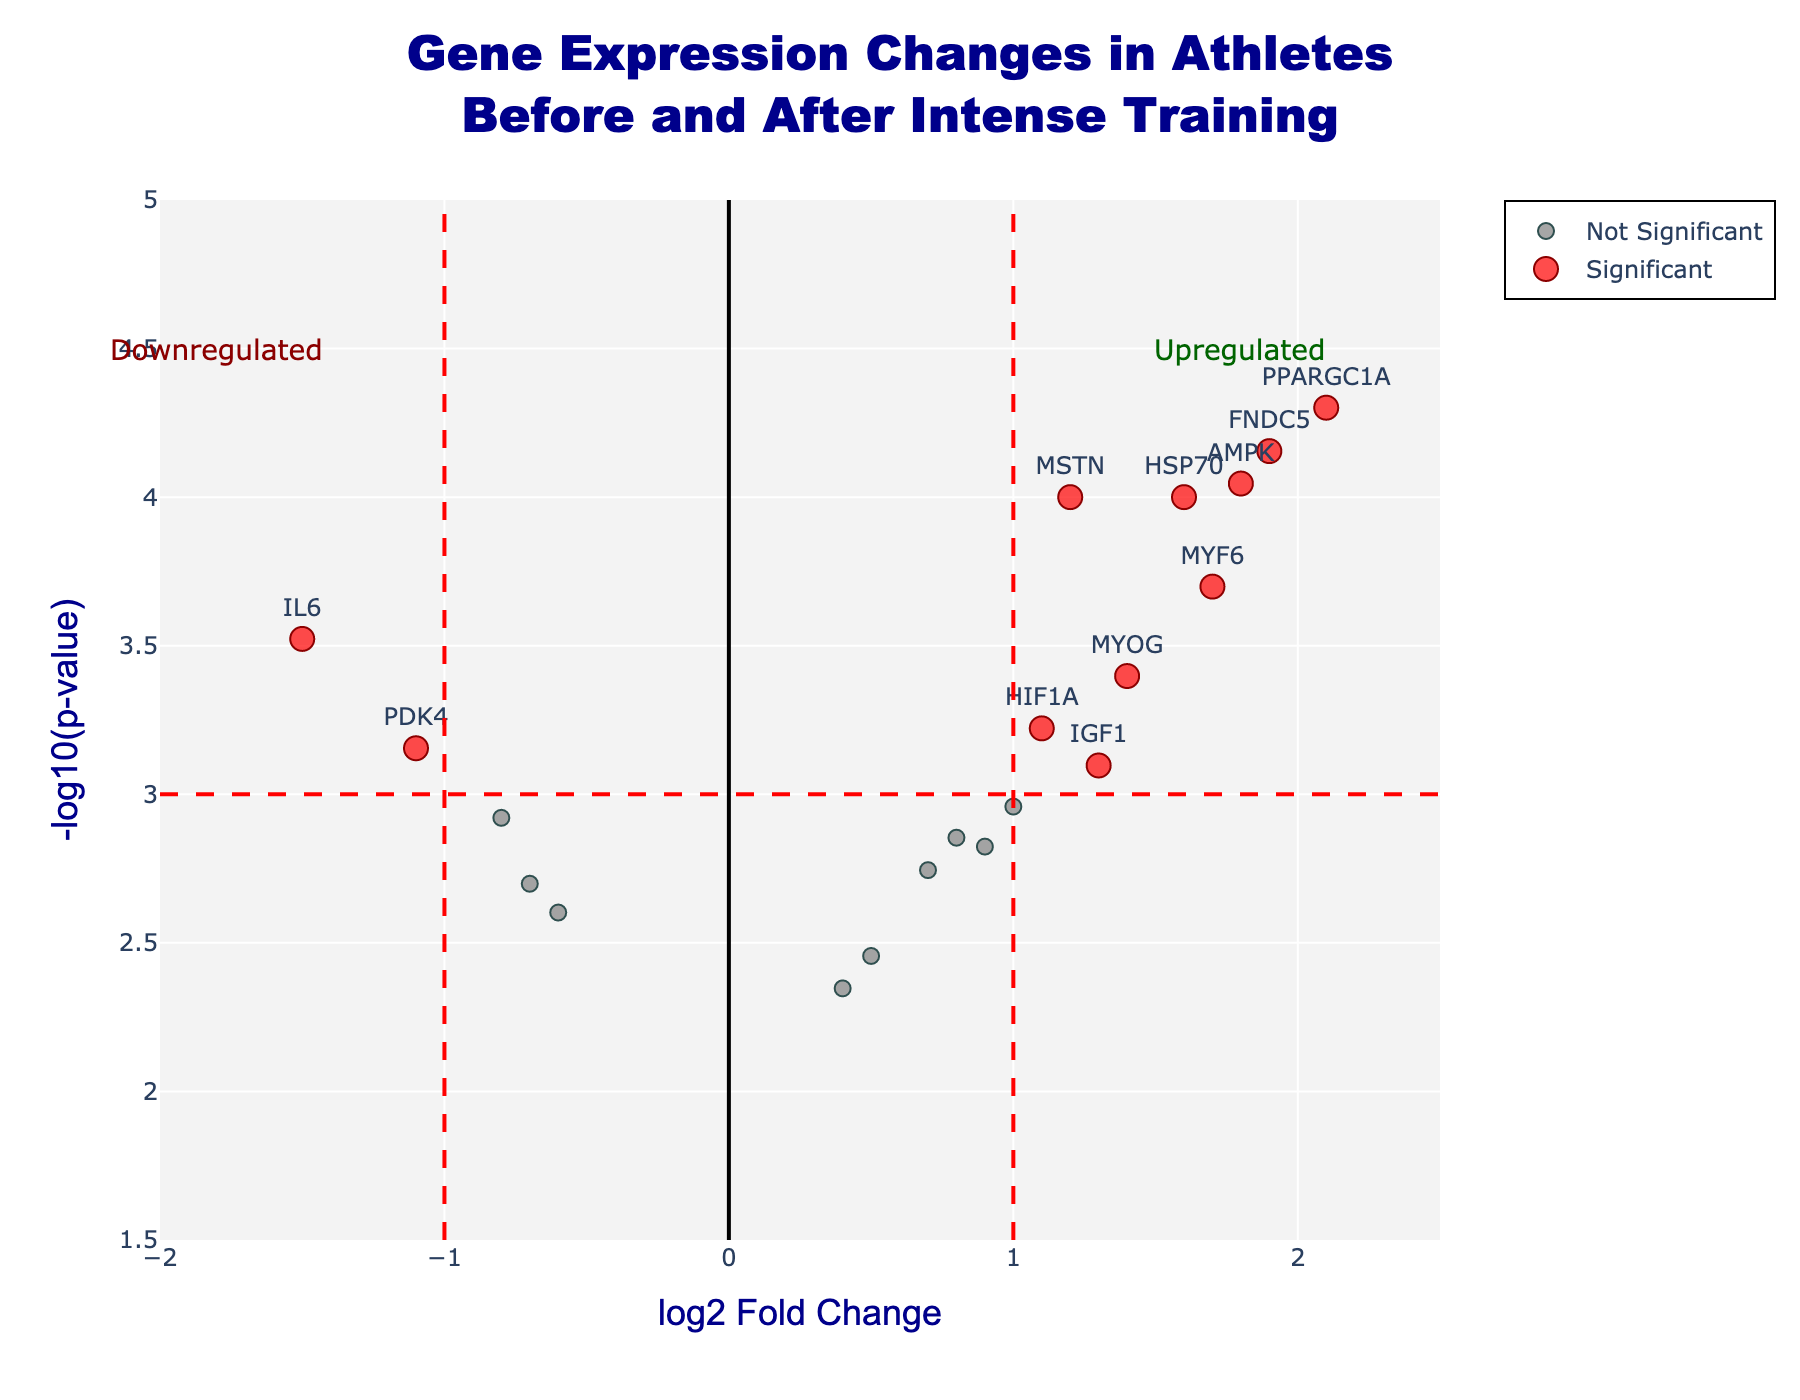What does the title of the Volcano Plot say? The title is located at the top of the plot and provides context about the data represented. Here, the title reads "Gene Expression Changes in Athletes Before and After Intense Training," indicating the focus on gene expression changes pre- and post-training.
Answer: "Gene Expression Changes in Athletes Before and After Intense Training" What are the axes labels and what do they represent? The x-axis is labeled "log2 Fold Change" which represents the logarithmic scale of gene expression changes, indicating upregulation or downregulation of genes. The y-axis is labeled "-log10(p-value)" which represents the significance of the gene expression changes, with higher values indicating higher significance.
Answer: x-axis: "log2 Fold Change", y-axis: "-log10(p-value)" How many genes are considered significant based on the plot? Significant genes are highlighted in red and labeled in the plot. Significant genes are those with a log2 Fold Change of greater than 1 or less than -1 and a p-value less than 0.001. By counting the red dots, we find there are 10 significant genes.
Answer: 10 Which gene shows the highest upregulation and what is its log2 Fold Change value? To find the highest upregulation, we look at the red points on the rightmost side of the x-axis. The gene "PPARGC1A" is at the top-right corner, with the highest positive log2 Fold Change value of 2.1.
Answer: PPARGC1A with a log2 Fold Change of 2.1 Which gene has the most significant downregulation and what is its -log10(p-value)? To find the most significant downregulation, look at the red points on the leftmost side of the x-axis. The gene "IL6" is on the extreme left, with a -log10(p-value) around 3.52.
Answer: IL6 with a -log10(p-value) of 3.52 Are there more upregulated or downregulated significant genes in this plot? Count the significant upregulated genes (red points on the right) and the significant downregulated genes (red points on the left). There are 7 upregulated and 3 downregulated significant genes, meaning there are more upregulated genes.
Answer: More upregulated genes Which gene has the highest -log10(p-value) among the significant ones and what is its value? The highest -log10(p-value) will be the red point highest on the y-axis. "PPARGC1A" stands highest among the significant genes with a -log10(p-value) of around 4.
Answer: PPARGC1A with -log10(p-value) of 4 What are genes around the log2 Fold Change value of 1 showing significant difference? By looking at the red points around the x-value of 1, the significant genes are "MSTN," "HIF1A," and "MTOR" with significant expression changes.
Answer: MSTN, HIF1A, MTOR What is the log2 Fold Change and -log10(p-value) range for non-significant genes in the plot? For non-significant genes (gray points), the range is all points falling outside the red dotted lines at log2 Fold Change ±1 and -log10(p-value) ≤ 3. The range is approximately from -2 to 2 on the x-axis and 1.5 to 2.5 on the y-axis.
Answer: log2 Fold Change: approximately -2 to 2, -log10(p-value): approximately 1.5 to 2.5 